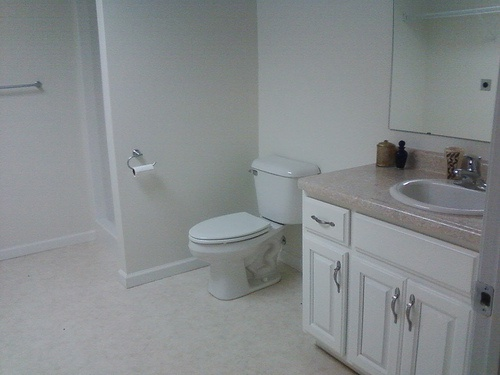Describe the objects in this image and their specific colors. I can see toilet in gray and darkgray tones, sink in gray tones, cup in gray and black tones, vase in gray and black tones, and bottle in black and gray tones in this image. 